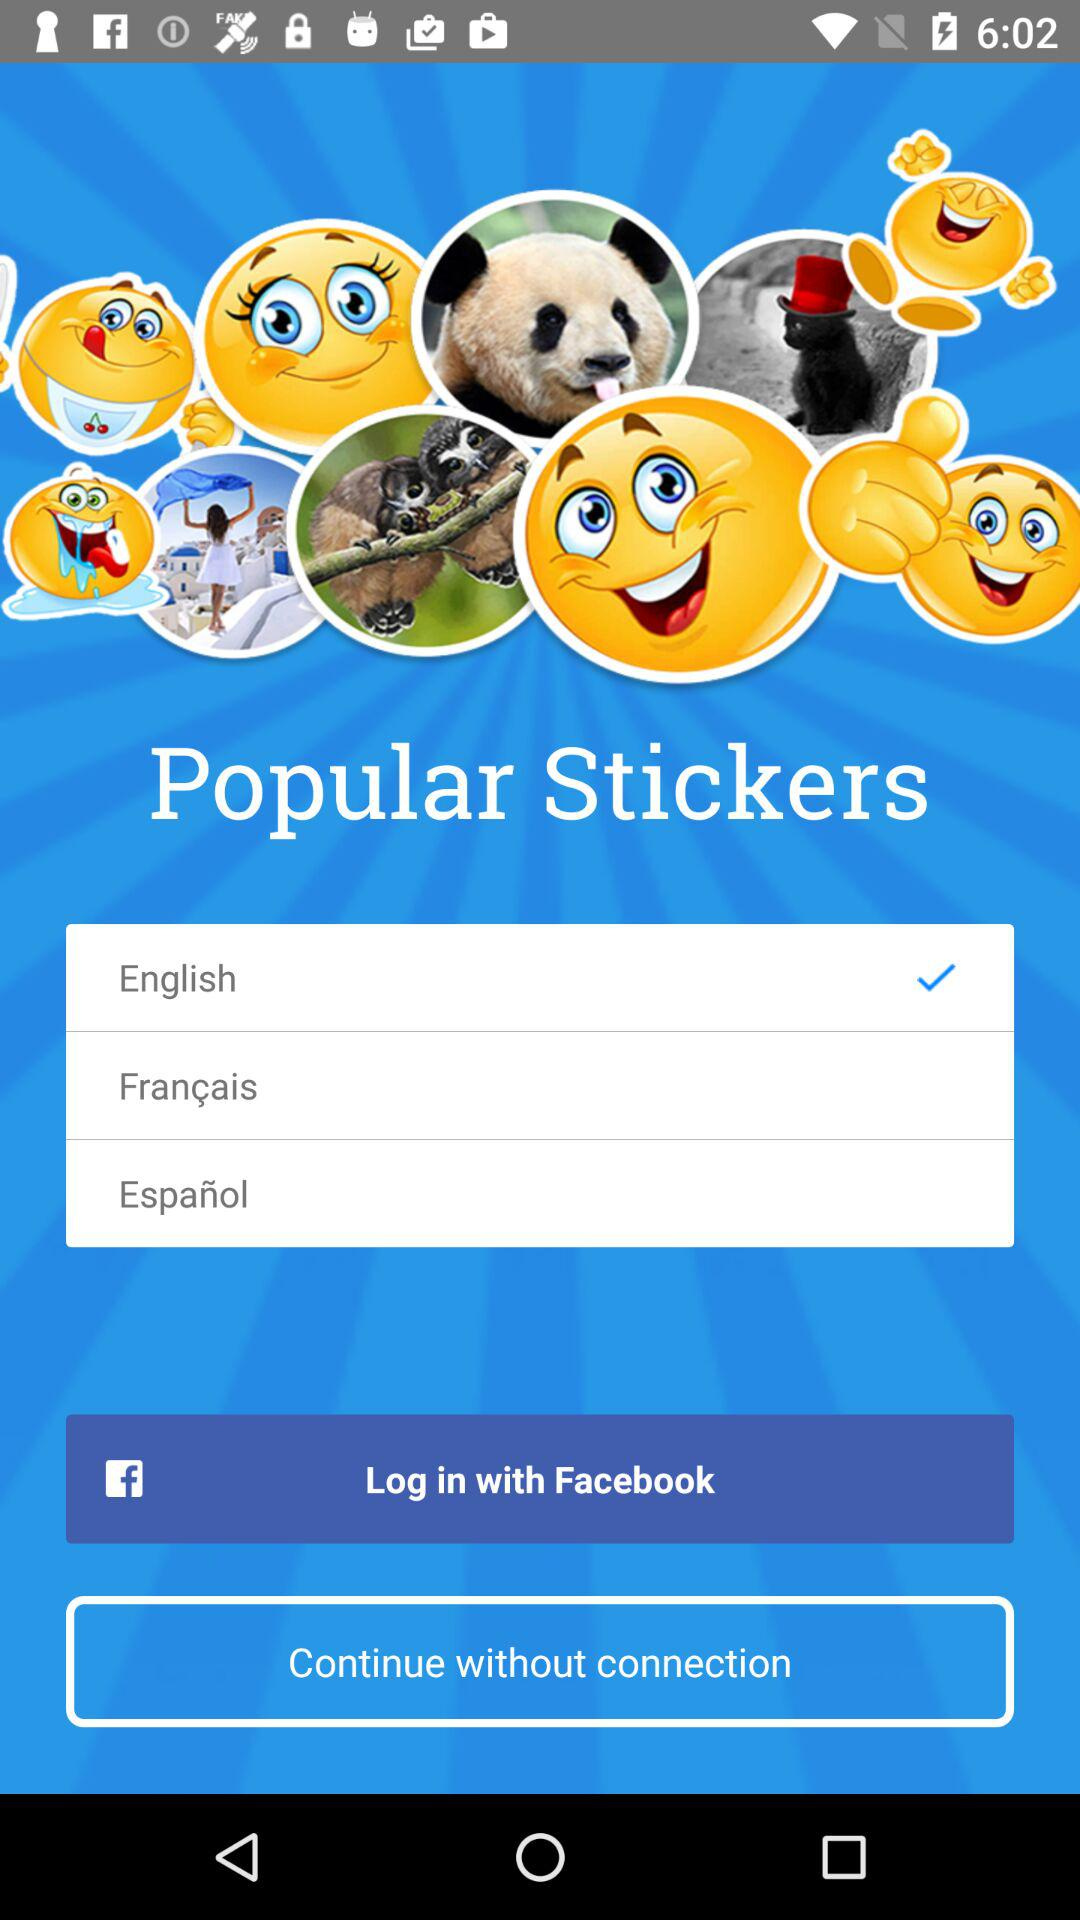Through what application can we log in? You can log in through "Facebook". 